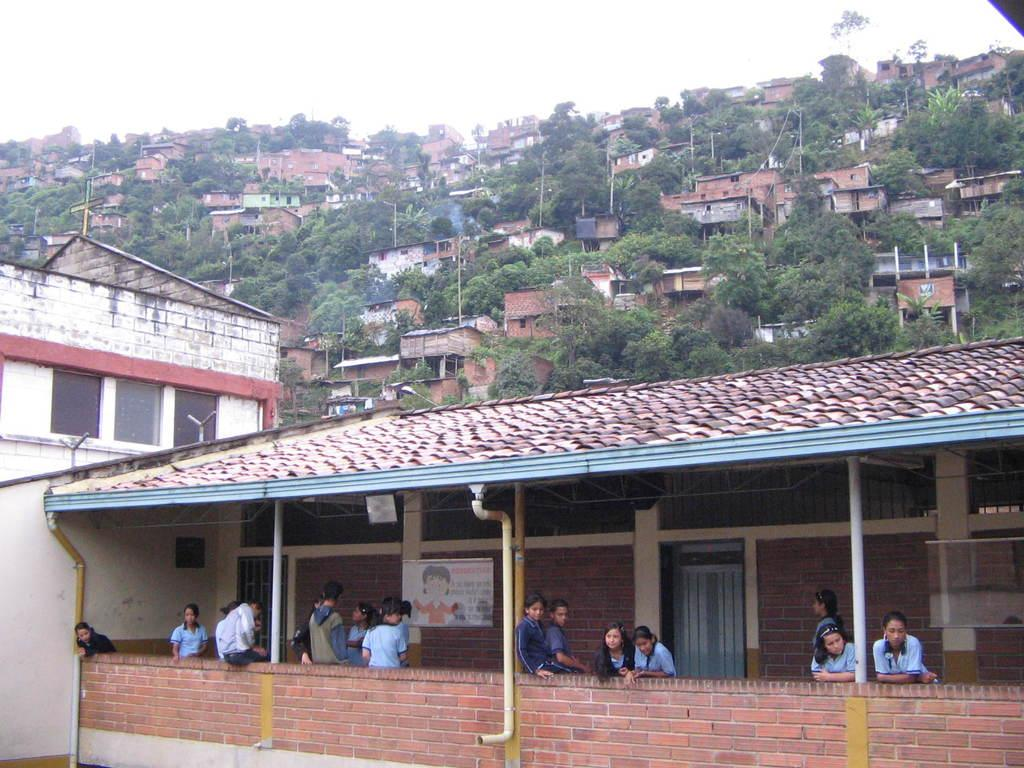Who or what can be seen in the image? There are people in the image. What is on the wall in the image? There is a poster on the wall in the image. What type of infrastructure is visible in the image? There are pipes and buildings visible in the image. What type of natural elements are present in the image? There are trees in the image. What other objects can be seen in the image? There are various objects in the image. What is visible in the background of the image? The sky is visible in the background of the image. What type of art is being argued about in the image? There is no art or argument present in the image; it features people, a poster, pipes, buildings, trees, various objects, and a visible sky. What type of crate is being used to store the objects in the image? There is no crate present in the image; it features people, a poster, pipes, buildings, trees, various objects, and a visible sky. 